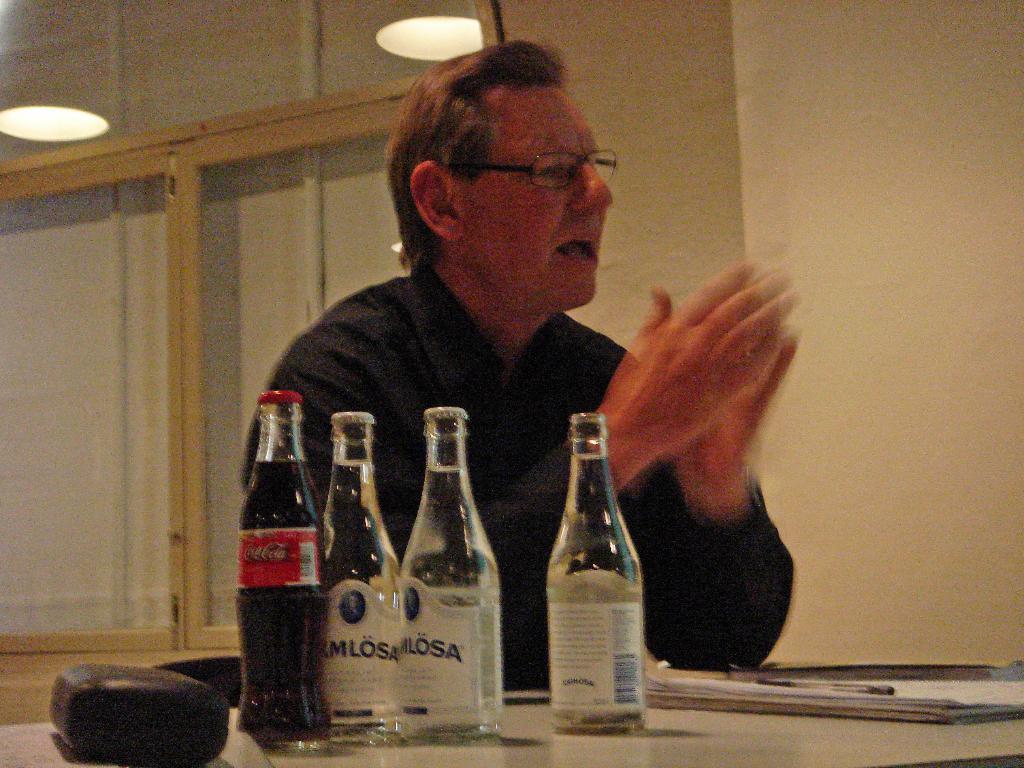What brand of soda is sitting on the table?
Give a very brief answer. Coca cola. 